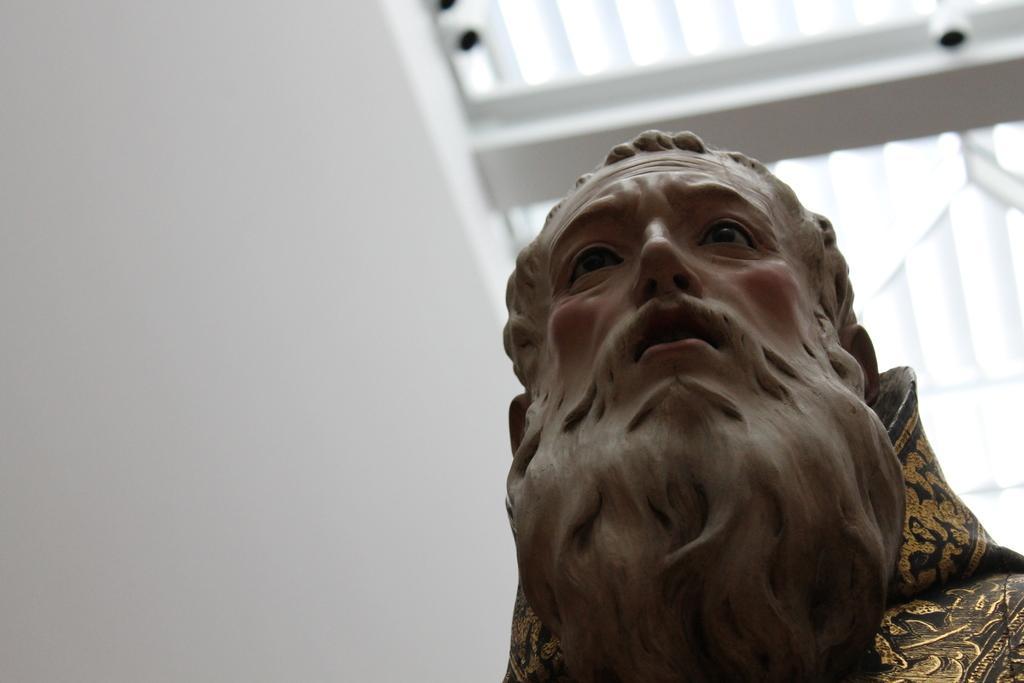Describe this image in one or two sentences. In front of the picture, we see the statue of the man. On the left side, we see a white wall. At the top, we see the CCTV cameras and the roof of the building in white color. 